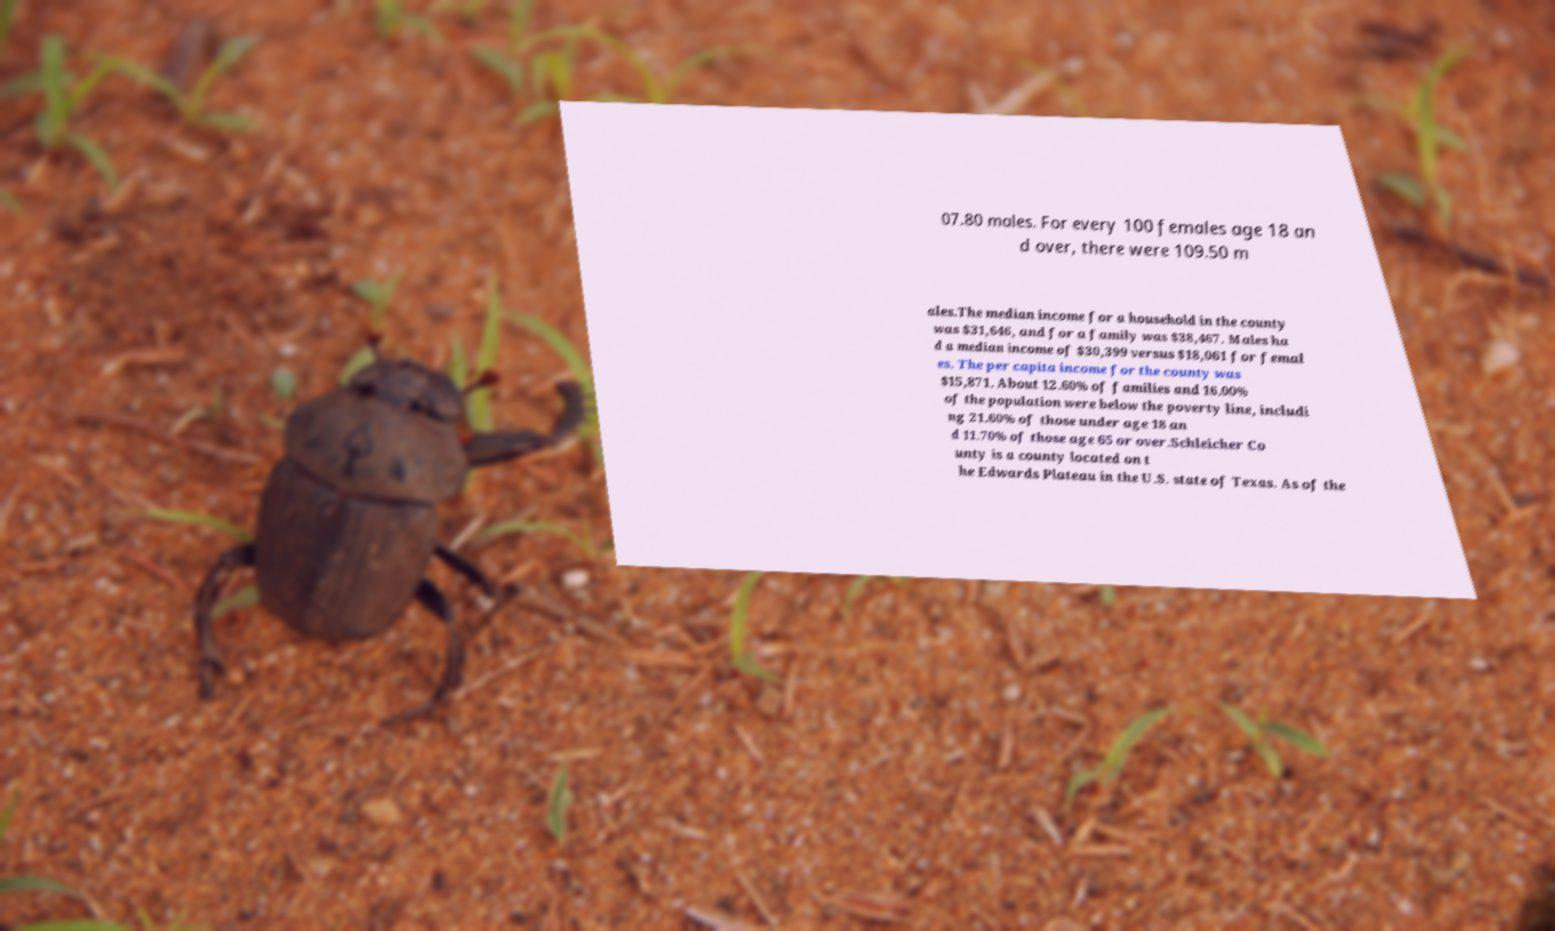Please read and relay the text visible in this image. What does it say? 07.80 males. For every 100 females age 18 an d over, there were 109.50 m ales.The median income for a household in the county was $31,646, and for a family was $38,467. Males ha d a median income of $30,399 versus $18,061 for femal es. The per capita income for the county was $15,871. About 12.60% of families and 16.00% of the population were below the poverty line, includi ng 21.60% of those under age 18 an d 11.70% of those age 65 or over.Schleicher Co unty is a county located on t he Edwards Plateau in the U.S. state of Texas. As of the 